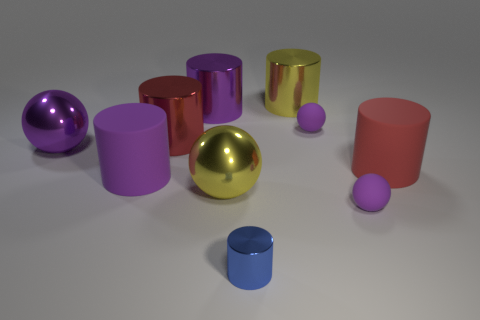How would you describe the arrangement of the colorful objects in this image? The objects are arranged in a somewhat scattered manner across a flat surface. There are various cylindrical shapes along with spheres, all featuring reflective surfaces. The colors are vibrant and include shades of purple, pink, blue, yellow, and gold. The arrangement does not follow a specific pattern and gives the impression of a random but visually pleasing distribution. 